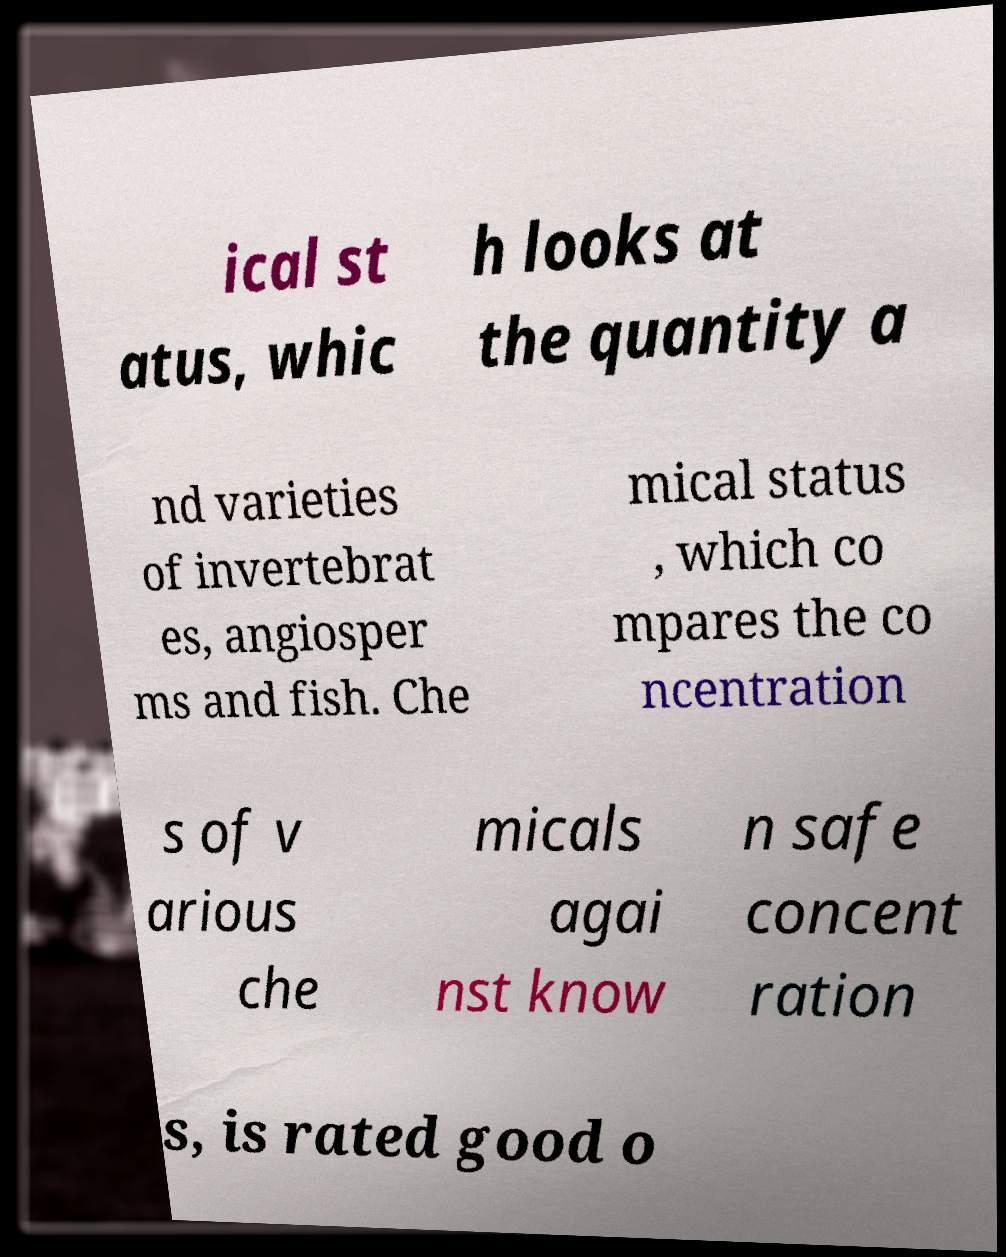Can you accurately transcribe the text from the provided image for me? ical st atus, whic h looks at the quantity a nd varieties of invertebrat es, angiosper ms and fish. Che mical status , which co mpares the co ncentration s of v arious che micals agai nst know n safe concent ration s, is rated good o 